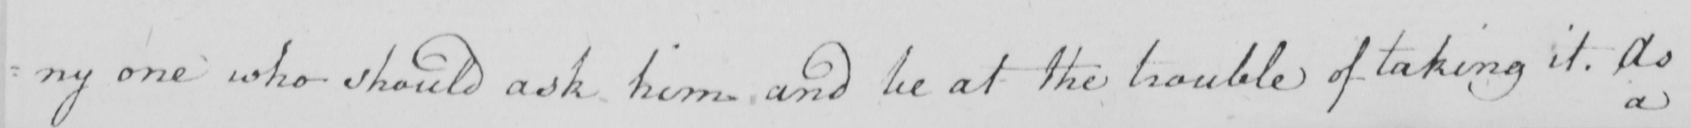What does this handwritten line say? : ny one who should ask him and be at the trouble of taking it . As 